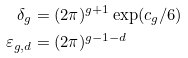<formula> <loc_0><loc_0><loc_500><loc_500>\delta _ { g } & = ( 2 \pi ) ^ { g + 1 } \exp ( c _ { g } / 6 ) \\ \varepsilon _ { g , d } & = ( 2 \pi ) ^ { g - 1 - d }</formula> 